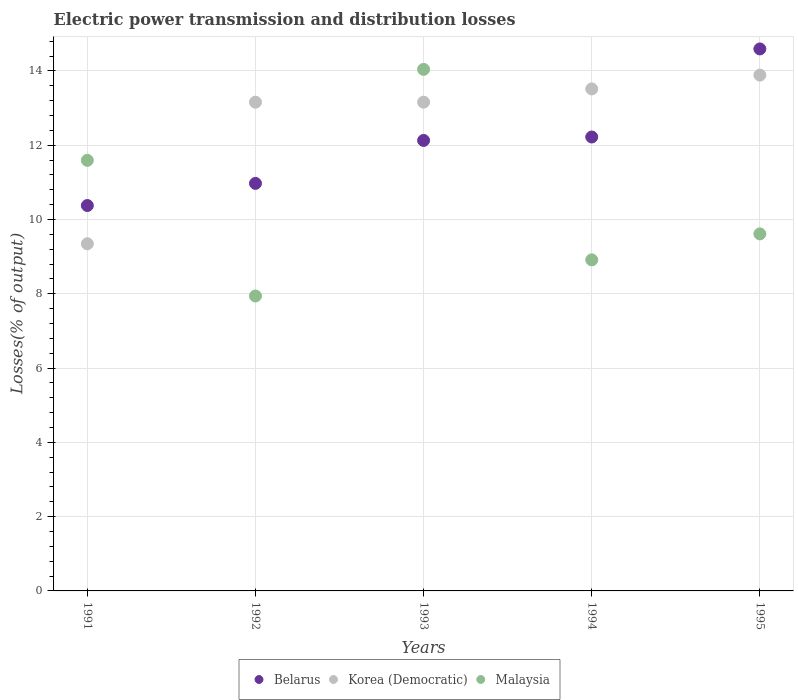How many different coloured dotlines are there?
Provide a succinct answer. 3. What is the electric power transmission and distribution losses in Malaysia in 1993?
Your response must be concise. 14.04. Across all years, what is the maximum electric power transmission and distribution losses in Korea (Democratic)?
Offer a terse response. 13.89. Across all years, what is the minimum electric power transmission and distribution losses in Belarus?
Give a very brief answer. 10.38. In which year was the electric power transmission and distribution losses in Korea (Democratic) maximum?
Give a very brief answer. 1995. What is the total electric power transmission and distribution losses in Korea (Democratic) in the graph?
Offer a very short reply. 63.06. What is the difference between the electric power transmission and distribution losses in Malaysia in 1993 and that in 1994?
Offer a very short reply. 5.13. What is the difference between the electric power transmission and distribution losses in Malaysia in 1991 and the electric power transmission and distribution losses in Belarus in 1995?
Give a very brief answer. -3. What is the average electric power transmission and distribution losses in Malaysia per year?
Provide a succinct answer. 10.42. In the year 1994, what is the difference between the electric power transmission and distribution losses in Malaysia and electric power transmission and distribution losses in Belarus?
Provide a short and direct response. -3.31. What is the ratio of the electric power transmission and distribution losses in Malaysia in 1991 to that in 1993?
Your answer should be compact. 0.83. Is the difference between the electric power transmission and distribution losses in Malaysia in 1992 and 1993 greater than the difference between the electric power transmission and distribution losses in Belarus in 1992 and 1993?
Keep it short and to the point. No. What is the difference between the highest and the second highest electric power transmission and distribution losses in Malaysia?
Ensure brevity in your answer.  2.45. What is the difference between the highest and the lowest electric power transmission and distribution losses in Malaysia?
Ensure brevity in your answer.  6.1. Is it the case that in every year, the sum of the electric power transmission and distribution losses in Korea (Democratic) and electric power transmission and distribution losses in Belarus  is greater than the electric power transmission and distribution losses in Malaysia?
Ensure brevity in your answer.  Yes. Does the electric power transmission and distribution losses in Malaysia monotonically increase over the years?
Your answer should be compact. No. Is the electric power transmission and distribution losses in Korea (Democratic) strictly greater than the electric power transmission and distribution losses in Malaysia over the years?
Ensure brevity in your answer.  No. Does the graph contain any zero values?
Your answer should be very brief. No. Does the graph contain grids?
Give a very brief answer. Yes. Where does the legend appear in the graph?
Make the answer very short. Bottom center. How many legend labels are there?
Offer a terse response. 3. How are the legend labels stacked?
Make the answer very short. Horizontal. What is the title of the graph?
Your answer should be very brief. Electric power transmission and distribution losses. What is the label or title of the X-axis?
Provide a short and direct response. Years. What is the label or title of the Y-axis?
Provide a short and direct response. Losses(% of output). What is the Losses(% of output) of Belarus in 1991?
Ensure brevity in your answer.  10.38. What is the Losses(% of output) in Korea (Democratic) in 1991?
Make the answer very short. 9.35. What is the Losses(% of output) in Malaysia in 1991?
Provide a succinct answer. 11.59. What is the Losses(% of output) of Belarus in 1992?
Make the answer very short. 10.97. What is the Losses(% of output) in Korea (Democratic) in 1992?
Keep it short and to the point. 13.16. What is the Losses(% of output) of Malaysia in 1992?
Provide a short and direct response. 7.94. What is the Losses(% of output) of Belarus in 1993?
Keep it short and to the point. 12.13. What is the Losses(% of output) in Korea (Democratic) in 1993?
Provide a short and direct response. 13.16. What is the Losses(% of output) in Malaysia in 1993?
Your response must be concise. 14.04. What is the Losses(% of output) of Belarus in 1994?
Your answer should be very brief. 12.22. What is the Losses(% of output) of Korea (Democratic) in 1994?
Keep it short and to the point. 13.52. What is the Losses(% of output) in Malaysia in 1994?
Provide a succinct answer. 8.91. What is the Losses(% of output) of Belarus in 1995?
Offer a very short reply. 14.59. What is the Losses(% of output) in Korea (Democratic) in 1995?
Make the answer very short. 13.89. What is the Losses(% of output) of Malaysia in 1995?
Provide a succinct answer. 9.61. Across all years, what is the maximum Losses(% of output) in Belarus?
Provide a succinct answer. 14.59. Across all years, what is the maximum Losses(% of output) of Korea (Democratic)?
Your response must be concise. 13.89. Across all years, what is the maximum Losses(% of output) in Malaysia?
Your response must be concise. 14.04. Across all years, what is the minimum Losses(% of output) of Belarus?
Give a very brief answer. 10.38. Across all years, what is the minimum Losses(% of output) in Korea (Democratic)?
Your answer should be very brief. 9.35. Across all years, what is the minimum Losses(% of output) in Malaysia?
Provide a succinct answer. 7.94. What is the total Losses(% of output) in Belarus in the graph?
Offer a very short reply. 60.29. What is the total Losses(% of output) of Korea (Democratic) in the graph?
Offer a very short reply. 63.06. What is the total Losses(% of output) in Malaysia in the graph?
Make the answer very short. 52.1. What is the difference between the Losses(% of output) in Belarus in 1991 and that in 1992?
Provide a short and direct response. -0.6. What is the difference between the Losses(% of output) in Korea (Democratic) in 1991 and that in 1992?
Your answer should be compact. -3.81. What is the difference between the Losses(% of output) in Malaysia in 1991 and that in 1992?
Your response must be concise. 3.65. What is the difference between the Losses(% of output) of Belarus in 1991 and that in 1993?
Ensure brevity in your answer.  -1.75. What is the difference between the Losses(% of output) in Korea (Democratic) in 1991 and that in 1993?
Ensure brevity in your answer.  -3.81. What is the difference between the Losses(% of output) in Malaysia in 1991 and that in 1993?
Your answer should be very brief. -2.45. What is the difference between the Losses(% of output) in Belarus in 1991 and that in 1994?
Offer a very short reply. -1.85. What is the difference between the Losses(% of output) of Korea (Democratic) in 1991 and that in 1994?
Your answer should be compact. -4.17. What is the difference between the Losses(% of output) in Malaysia in 1991 and that in 1994?
Ensure brevity in your answer.  2.68. What is the difference between the Losses(% of output) of Belarus in 1991 and that in 1995?
Your response must be concise. -4.22. What is the difference between the Losses(% of output) in Korea (Democratic) in 1991 and that in 1995?
Keep it short and to the point. -4.54. What is the difference between the Losses(% of output) of Malaysia in 1991 and that in 1995?
Offer a very short reply. 1.98. What is the difference between the Losses(% of output) of Belarus in 1992 and that in 1993?
Ensure brevity in your answer.  -1.16. What is the difference between the Losses(% of output) in Korea (Democratic) in 1992 and that in 1993?
Your response must be concise. -0. What is the difference between the Losses(% of output) of Malaysia in 1992 and that in 1993?
Keep it short and to the point. -6.1. What is the difference between the Losses(% of output) in Belarus in 1992 and that in 1994?
Your response must be concise. -1.25. What is the difference between the Losses(% of output) of Korea (Democratic) in 1992 and that in 1994?
Keep it short and to the point. -0.36. What is the difference between the Losses(% of output) of Malaysia in 1992 and that in 1994?
Ensure brevity in your answer.  -0.97. What is the difference between the Losses(% of output) in Belarus in 1992 and that in 1995?
Give a very brief answer. -3.62. What is the difference between the Losses(% of output) in Korea (Democratic) in 1992 and that in 1995?
Keep it short and to the point. -0.73. What is the difference between the Losses(% of output) in Malaysia in 1992 and that in 1995?
Provide a short and direct response. -1.67. What is the difference between the Losses(% of output) of Belarus in 1993 and that in 1994?
Your response must be concise. -0.09. What is the difference between the Losses(% of output) in Korea (Democratic) in 1993 and that in 1994?
Your answer should be very brief. -0.36. What is the difference between the Losses(% of output) in Malaysia in 1993 and that in 1994?
Keep it short and to the point. 5.13. What is the difference between the Losses(% of output) in Belarus in 1993 and that in 1995?
Ensure brevity in your answer.  -2.46. What is the difference between the Losses(% of output) in Korea (Democratic) in 1993 and that in 1995?
Your answer should be compact. -0.73. What is the difference between the Losses(% of output) in Malaysia in 1993 and that in 1995?
Provide a short and direct response. 4.43. What is the difference between the Losses(% of output) of Belarus in 1994 and that in 1995?
Your answer should be compact. -2.37. What is the difference between the Losses(% of output) in Korea (Democratic) in 1994 and that in 1995?
Your answer should be compact. -0.37. What is the difference between the Losses(% of output) in Malaysia in 1994 and that in 1995?
Your answer should be very brief. -0.7. What is the difference between the Losses(% of output) in Belarus in 1991 and the Losses(% of output) in Korea (Democratic) in 1992?
Provide a succinct answer. -2.78. What is the difference between the Losses(% of output) of Belarus in 1991 and the Losses(% of output) of Malaysia in 1992?
Make the answer very short. 2.44. What is the difference between the Losses(% of output) in Korea (Democratic) in 1991 and the Losses(% of output) in Malaysia in 1992?
Your answer should be very brief. 1.41. What is the difference between the Losses(% of output) in Belarus in 1991 and the Losses(% of output) in Korea (Democratic) in 1993?
Your answer should be compact. -2.78. What is the difference between the Losses(% of output) of Belarus in 1991 and the Losses(% of output) of Malaysia in 1993?
Your answer should be compact. -3.67. What is the difference between the Losses(% of output) of Korea (Democratic) in 1991 and the Losses(% of output) of Malaysia in 1993?
Ensure brevity in your answer.  -4.7. What is the difference between the Losses(% of output) in Belarus in 1991 and the Losses(% of output) in Korea (Democratic) in 1994?
Offer a terse response. -3.14. What is the difference between the Losses(% of output) of Belarus in 1991 and the Losses(% of output) of Malaysia in 1994?
Offer a terse response. 1.46. What is the difference between the Losses(% of output) in Korea (Democratic) in 1991 and the Losses(% of output) in Malaysia in 1994?
Keep it short and to the point. 0.43. What is the difference between the Losses(% of output) in Belarus in 1991 and the Losses(% of output) in Korea (Democratic) in 1995?
Your answer should be compact. -3.51. What is the difference between the Losses(% of output) in Belarus in 1991 and the Losses(% of output) in Malaysia in 1995?
Your answer should be compact. 0.76. What is the difference between the Losses(% of output) of Korea (Democratic) in 1991 and the Losses(% of output) of Malaysia in 1995?
Your response must be concise. -0.27. What is the difference between the Losses(% of output) of Belarus in 1992 and the Losses(% of output) of Korea (Democratic) in 1993?
Your response must be concise. -2.19. What is the difference between the Losses(% of output) in Belarus in 1992 and the Losses(% of output) in Malaysia in 1993?
Your answer should be compact. -3.07. What is the difference between the Losses(% of output) of Korea (Democratic) in 1992 and the Losses(% of output) of Malaysia in 1993?
Provide a short and direct response. -0.88. What is the difference between the Losses(% of output) in Belarus in 1992 and the Losses(% of output) in Korea (Democratic) in 1994?
Offer a terse response. -2.54. What is the difference between the Losses(% of output) in Belarus in 1992 and the Losses(% of output) in Malaysia in 1994?
Provide a succinct answer. 2.06. What is the difference between the Losses(% of output) of Korea (Democratic) in 1992 and the Losses(% of output) of Malaysia in 1994?
Offer a very short reply. 4.24. What is the difference between the Losses(% of output) in Belarus in 1992 and the Losses(% of output) in Korea (Democratic) in 1995?
Your answer should be compact. -2.91. What is the difference between the Losses(% of output) in Belarus in 1992 and the Losses(% of output) in Malaysia in 1995?
Your response must be concise. 1.36. What is the difference between the Losses(% of output) in Korea (Democratic) in 1992 and the Losses(% of output) in Malaysia in 1995?
Your response must be concise. 3.55. What is the difference between the Losses(% of output) of Belarus in 1993 and the Losses(% of output) of Korea (Democratic) in 1994?
Provide a short and direct response. -1.39. What is the difference between the Losses(% of output) in Belarus in 1993 and the Losses(% of output) in Malaysia in 1994?
Your answer should be compact. 3.21. What is the difference between the Losses(% of output) of Korea (Democratic) in 1993 and the Losses(% of output) of Malaysia in 1994?
Your response must be concise. 4.25. What is the difference between the Losses(% of output) of Belarus in 1993 and the Losses(% of output) of Korea (Democratic) in 1995?
Ensure brevity in your answer.  -1.76. What is the difference between the Losses(% of output) in Belarus in 1993 and the Losses(% of output) in Malaysia in 1995?
Provide a succinct answer. 2.52. What is the difference between the Losses(% of output) of Korea (Democratic) in 1993 and the Losses(% of output) of Malaysia in 1995?
Give a very brief answer. 3.55. What is the difference between the Losses(% of output) in Belarus in 1994 and the Losses(% of output) in Korea (Democratic) in 1995?
Keep it short and to the point. -1.67. What is the difference between the Losses(% of output) in Belarus in 1994 and the Losses(% of output) in Malaysia in 1995?
Your answer should be compact. 2.61. What is the difference between the Losses(% of output) of Korea (Democratic) in 1994 and the Losses(% of output) of Malaysia in 1995?
Ensure brevity in your answer.  3.9. What is the average Losses(% of output) in Belarus per year?
Your response must be concise. 12.06. What is the average Losses(% of output) in Korea (Democratic) per year?
Keep it short and to the point. 12.61. What is the average Losses(% of output) of Malaysia per year?
Your answer should be compact. 10.42. In the year 1991, what is the difference between the Losses(% of output) of Belarus and Losses(% of output) of Korea (Democratic)?
Your answer should be very brief. 1.03. In the year 1991, what is the difference between the Losses(% of output) in Belarus and Losses(% of output) in Malaysia?
Make the answer very short. -1.22. In the year 1991, what is the difference between the Losses(% of output) in Korea (Democratic) and Losses(% of output) in Malaysia?
Ensure brevity in your answer.  -2.25. In the year 1992, what is the difference between the Losses(% of output) of Belarus and Losses(% of output) of Korea (Democratic)?
Ensure brevity in your answer.  -2.19. In the year 1992, what is the difference between the Losses(% of output) in Belarus and Losses(% of output) in Malaysia?
Your response must be concise. 3.03. In the year 1992, what is the difference between the Losses(% of output) of Korea (Democratic) and Losses(% of output) of Malaysia?
Your answer should be very brief. 5.22. In the year 1993, what is the difference between the Losses(% of output) in Belarus and Losses(% of output) in Korea (Democratic)?
Offer a very short reply. -1.03. In the year 1993, what is the difference between the Losses(% of output) in Belarus and Losses(% of output) in Malaysia?
Give a very brief answer. -1.91. In the year 1993, what is the difference between the Losses(% of output) of Korea (Democratic) and Losses(% of output) of Malaysia?
Your response must be concise. -0.88. In the year 1994, what is the difference between the Losses(% of output) of Belarus and Losses(% of output) of Korea (Democratic)?
Give a very brief answer. -1.29. In the year 1994, what is the difference between the Losses(% of output) of Belarus and Losses(% of output) of Malaysia?
Make the answer very short. 3.31. In the year 1994, what is the difference between the Losses(% of output) in Korea (Democratic) and Losses(% of output) in Malaysia?
Provide a short and direct response. 4.6. In the year 1995, what is the difference between the Losses(% of output) of Belarus and Losses(% of output) of Korea (Democratic)?
Provide a short and direct response. 0.7. In the year 1995, what is the difference between the Losses(% of output) of Belarus and Losses(% of output) of Malaysia?
Keep it short and to the point. 4.98. In the year 1995, what is the difference between the Losses(% of output) of Korea (Democratic) and Losses(% of output) of Malaysia?
Offer a very short reply. 4.27. What is the ratio of the Losses(% of output) in Belarus in 1991 to that in 1992?
Your response must be concise. 0.95. What is the ratio of the Losses(% of output) in Korea (Democratic) in 1991 to that in 1992?
Keep it short and to the point. 0.71. What is the ratio of the Losses(% of output) of Malaysia in 1991 to that in 1992?
Your answer should be very brief. 1.46. What is the ratio of the Losses(% of output) in Belarus in 1991 to that in 1993?
Make the answer very short. 0.86. What is the ratio of the Losses(% of output) in Korea (Democratic) in 1991 to that in 1993?
Provide a succinct answer. 0.71. What is the ratio of the Losses(% of output) in Malaysia in 1991 to that in 1993?
Give a very brief answer. 0.83. What is the ratio of the Losses(% of output) in Belarus in 1991 to that in 1994?
Your answer should be very brief. 0.85. What is the ratio of the Losses(% of output) of Korea (Democratic) in 1991 to that in 1994?
Your response must be concise. 0.69. What is the ratio of the Losses(% of output) of Malaysia in 1991 to that in 1994?
Your answer should be compact. 1.3. What is the ratio of the Losses(% of output) of Belarus in 1991 to that in 1995?
Ensure brevity in your answer.  0.71. What is the ratio of the Losses(% of output) of Korea (Democratic) in 1991 to that in 1995?
Keep it short and to the point. 0.67. What is the ratio of the Losses(% of output) in Malaysia in 1991 to that in 1995?
Offer a very short reply. 1.21. What is the ratio of the Losses(% of output) of Belarus in 1992 to that in 1993?
Provide a short and direct response. 0.9. What is the ratio of the Losses(% of output) in Malaysia in 1992 to that in 1993?
Provide a short and direct response. 0.57. What is the ratio of the Losses(% of output) in Belarus in 1992 to that in 1994?
Offer a terse response. 0.9. What is the ratio of the Losses(% of output) of Korea (Democratic) in 1992 to that in 1994?
Your answer should be very brief. 0.97. What is the ratio of the Losses(% of output) of Malaysia in 1992 to that in 1994?
Offer a very short reply. 0.89. What is the ratio of the Losses(% of output) in Belarus in 1992 to that in 1995?
Keep it short and to the point. 0.75. What is the ratio of the Losses(% of output) in Korea (Democratic) in 1992 to that in 1995?
Keep it short and to the point. 0.95. What is the ratio of the Losses(% of output) in Malaysia in 1992 to that in 1995?
Your answer should be compact. 0.83. What is the ratio of the Losses(% of output) of Korea (Democratic) in 1993 to that in 1994?
Your answer should be very brief. 0.97. What is the ratio of the Losses(% of output) of Malaysia in 1993 to that in 1994?
Your answer should be very brief. 1.58. What is the ratio of the Losses(% of output) of Belarus in 1993 to that in 1995?
Provide a short and direct response. 0.83. What is the ratio of the Losses(% of output) in Korea (Democratic) in 1993 to that in 1995?
Your answer should be compact. 0.95. What is the ratio of the Losses(% of output) of Malaysia in 1993 to that in 1995?
Keep it short and to the point. 1.46. What is the ratio of the Losses(% of output) in Belarus in 1994 to that in 1995?
Keep it short and to the point. 0.84. What is the ratio of the Losses(% of output) in Korea (Democratic) in 1994 to that in 1995?
Offer a very short reply. 0.97. What is the ratio of the Losses(% of output) in Malaysia in 1994 to that in 1995?
Make the answer very short. 0.93. What is the difference between the highest and the second highest Losses(% of output) of Belarus?
Offer a very short reply. 2.37. What is the difference between the highest and the second highest Losses(% of output) of Korea (Democratic)?
Keep it short and to the point. 0.37. What is the difference between the highest and the second highest Losses(% of output) of Malaysia?
Your response must be concise. 2.45. What is the difference between the highest and the lowest Losses(% of output) in Belarus?
Provide a short and direct response. 4.22. What is the difference between the highest and the lowest Losses(% of output) in Korea (Democratic)?
Give a very brief answer. 4.54. What is the difference between the highest and the lowest Losses(% of output) of Malaysia?
Your answer should be very brief. 6.1. 